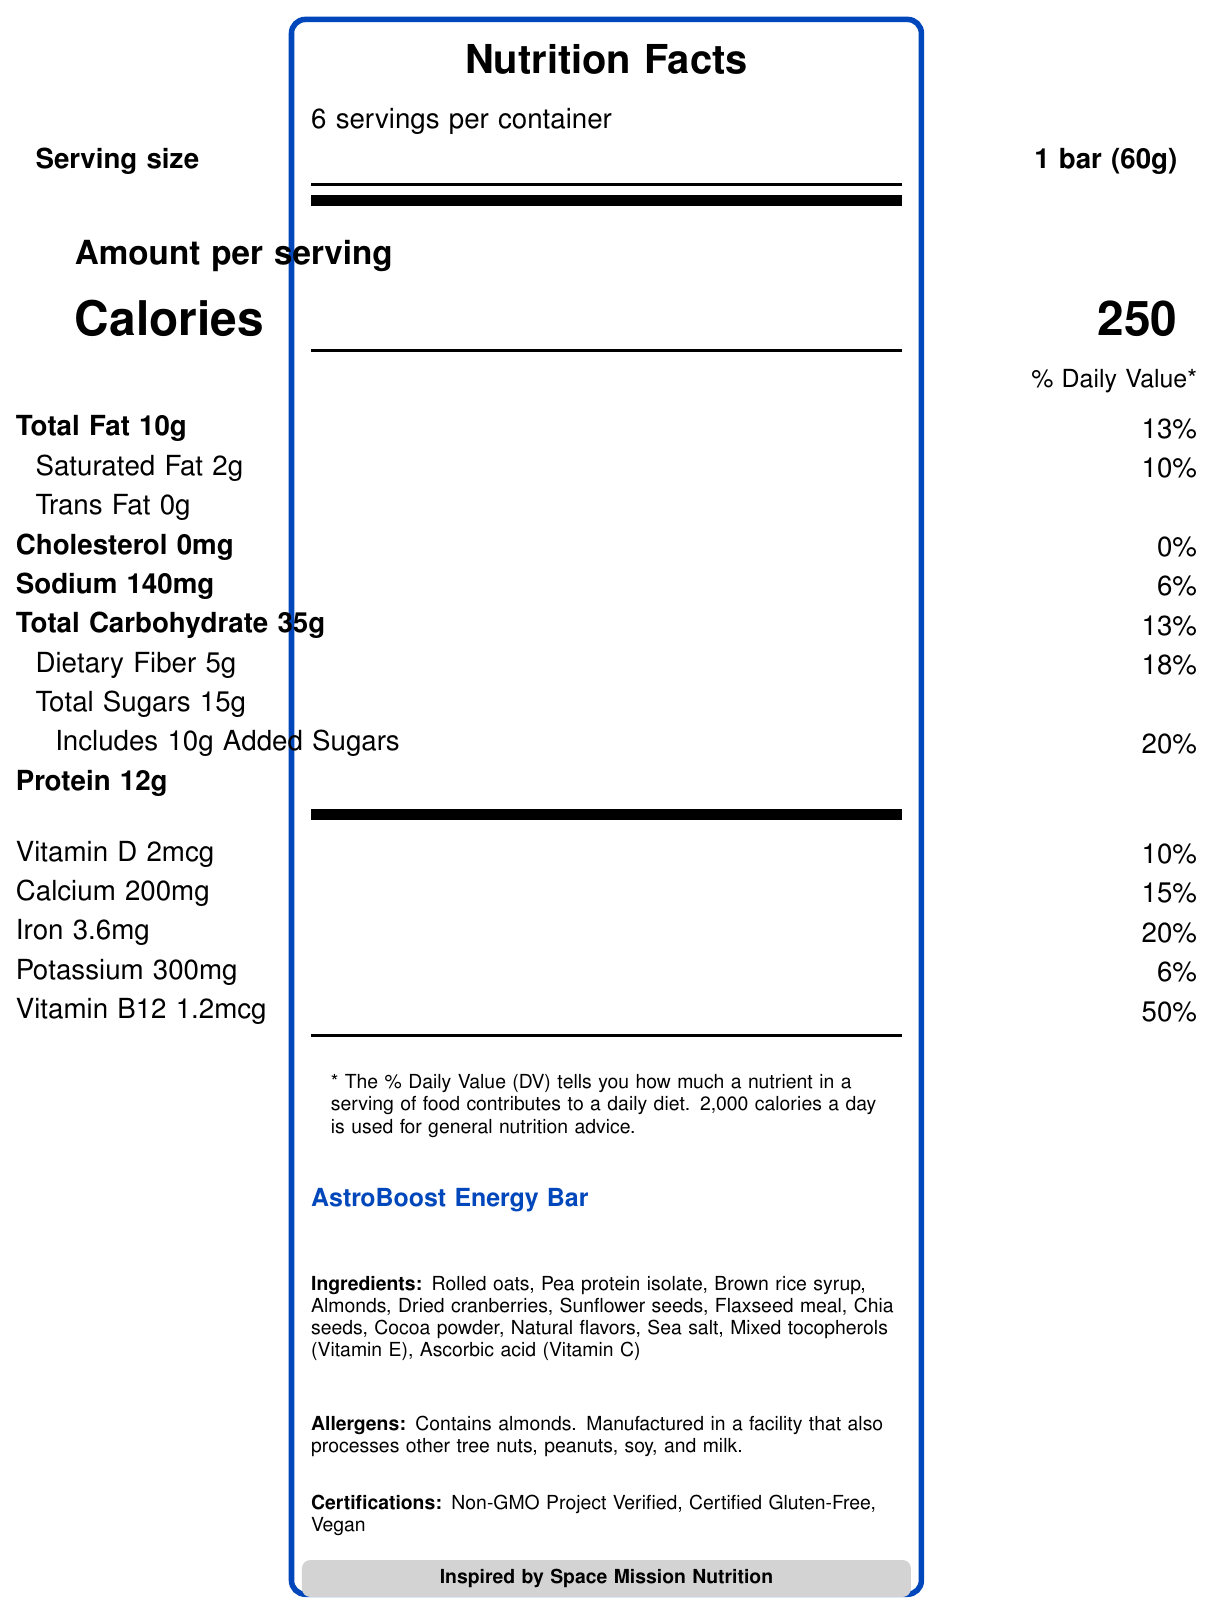What is the serving size of the AstroBoost Energy Bar? The serving size is clearly indicated on the Nutrition Facts Label as 1 bar (60g).
Answer: 1 bar (60g) How many servings are there per container? The document states that there are 6 servings per container.
Answer: 6 servings How many calories does one AstroBoost Energy Bar provide? The number of calories per serving is listed on the Nutrition Facts Label as 250 calories.
Answer: 250 calories What percentage of the daily value for dietary fiber does one AstroBoost Energy Bar provide? The Nutrition Facts Label indicates that one serving provides 18% of the daily value for dietary fiber.
Answer: 18% What is the recommended use of the AstroBoost Energy Bar? The recommended use is specified directly in the document.
Answer: Consume as a meal replacement or high-energy snack during intense physical or mental activities. Ideal for astronauts, athletes, hikers, and busy professionals. Does the AstroBoost Energy Bar contain any added sugars? The label indicates that the bar includes 10g of added sugars.
Answer: Yes What are the total sugars in the AstroBoost Energy Bar? A. 10g B. 12g C. 15g D. 18g According to the Nutrition Facts, the total sugars amount to 15g.
Answer: C. 15g Which certifications does the AstroBoost Energy Bar have? A. Non-GMO Project Verified B. Certified Gluten-Free C. Vegan D. All of the above The document lists all these certifications: Non-GMO Project Verified, Certified Gluten-Free, and Vegan.
Answer: D. All of the above Is the product suitable for someone with an almond allergy? The allergens section clearly states that the product contains almonds, making it unsuitable for someone with an almond allergy.
Answer: No Summarize the main idea of the document The document provides comprehensive details about the AstroBoost Energy Bar, including its nutritional content, ingredients, recommended use, certifications, storage instructions, and environmental sustainability.
Answer: AstroBoost Energy Bar is a nutrient-dense snack inspired by space mission nutrition, developed with NASA food scientists. It's intended for high-energy requirements and provides balanced macro and micronutrients, with certifications like Non-GMO, Gluten-Free, and Vegan. The product is tailored for health-conscious individuals and has a long shelf life. What are the omega-3 fatty acids' amounts in one serving? Although omega-3 fatty acids are mentioned in the data, their amount is not provided in the visual document.
Answer: Not specified visually on the document What is the total fat content per serving? The Nutrition Facts Label specifies 10g of total fat per serving.
Answer: 10g What processing technique highlights the innovation of this product? The document does not provide visual information on specific processing techniques used to highlight the innovation of the product.
Answer: Cannot be determined 